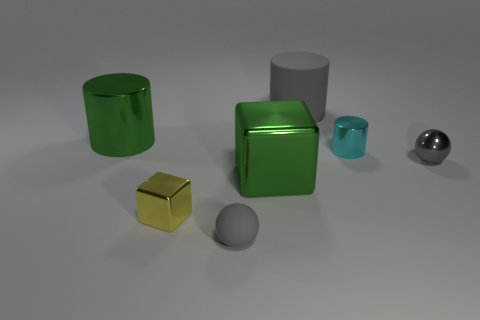Is the material of the gray cylinder behind the metallic ball the same as the green thing behind the gray shiny object?
Keep it short and to the point. No. Are there any other things that have the same material as the small cube?
Your answer should be compact. Yes. Is the shape of the gray matte object that is in front of the large rubber thing the same as the gray shiny thing that is right of the yellow metal cube?
Provide a succinct answer. Yes. Is the number of gray metallic things that are left of the green metallic cylinder less than the number of tiny green spheres?
Your response must be concise. No. How many big matte cylinders have the same color as the tiny metallic sphere?
Your answer should be compact. 1. There is a gray cylinder that is behind the green cube; how big is it?
Provide a succinct answer. Large. What is the shape of the small shiny object that is left of the big metallic object that is right of the big thing that is left of the green block?
Provide a succinct answer. Cube. There is a gray object that is both in front of the big green cylinder and right of the green metal cube; what shape is it?
Your answer should be very brief. Sphere. Is there another yellow block that has the same size as the yellow metallic cube?
Provide a succinct answer. No. Does the matte object that is to the left of the large gray rubber cylinder have the same shape as the gray metal object?
Provide a short and direct response. Yes. 